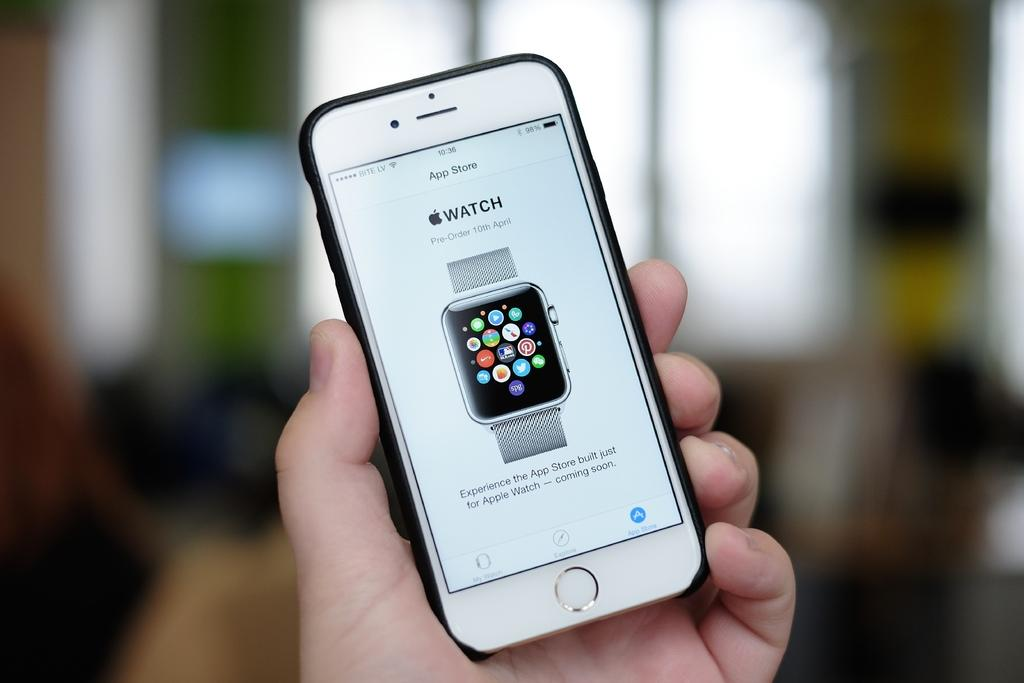<image>
Describe the image concisely. A hand is holding an iPhone which is displaying an Apple Watch on the App Store. 